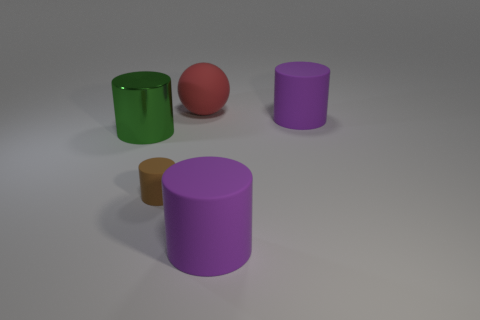Add 4 brown matte cylinders. How many objects exist? 9 Subtract all balls. How many objects are left? 4 Add 2 tiny brown cylinders. How many tiny brown cylinders are left? 3 Add 4 small green rubber cubes. How many small green rubber cubes exist? 4 Subtract 0 gray cylinders. How many objects are left? 5 Subtract all green metal things. Subtract all purple objects. How many objects are left? 2 